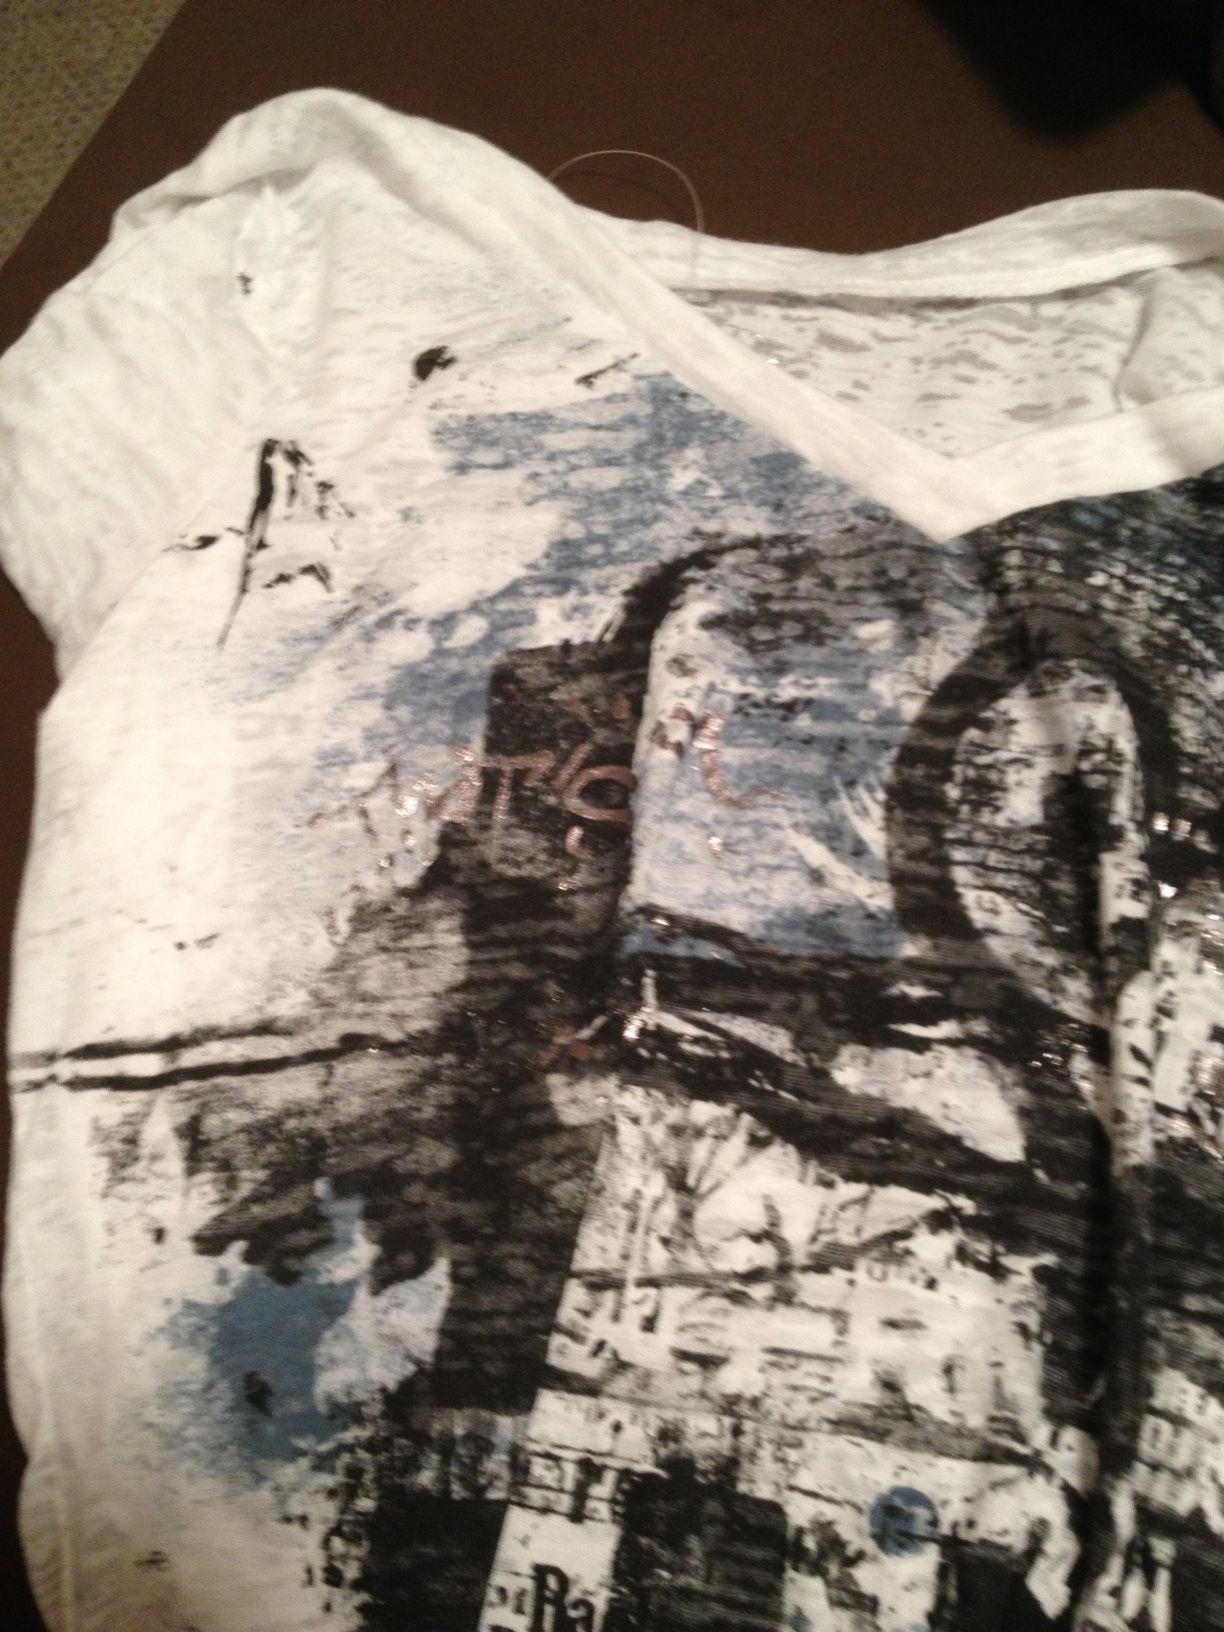What does this shirt say? Please and thank you. The shirt doesn't appear to have any readable wording. It seems to feature an abstract design with possibly some text that is not fully legible. 